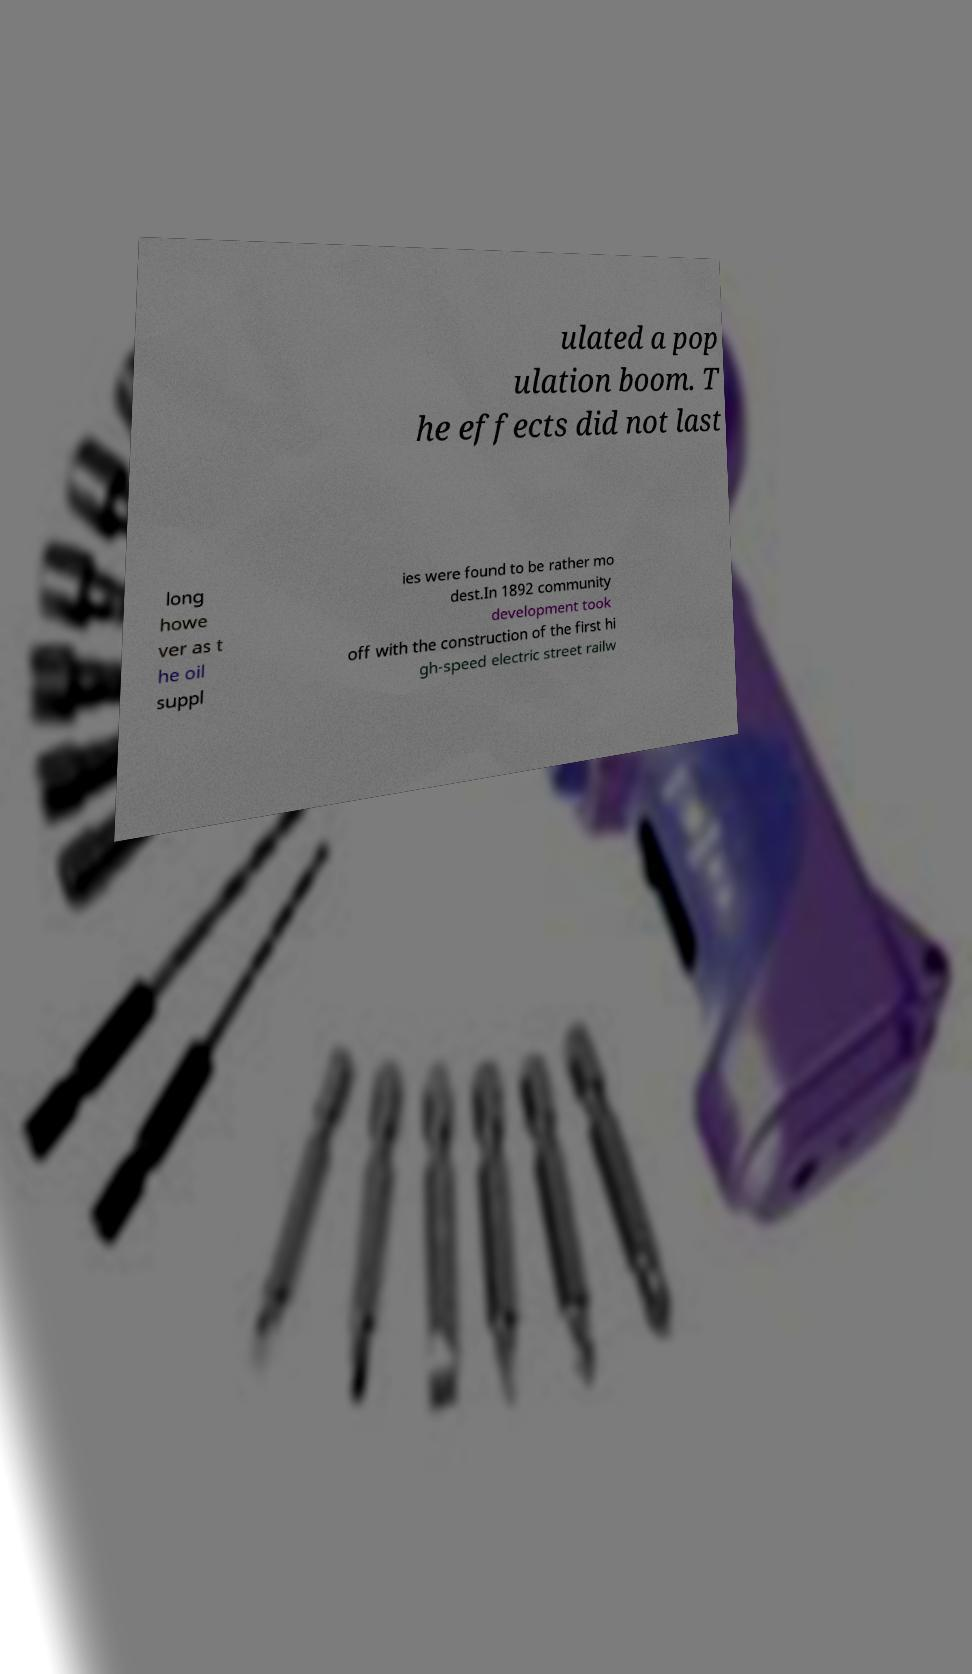Could you extract and type out the text from this image? ulated a pop ulation boom. T he effects did not last long howe ver as t he oil suppl ies were found to be rather mo dest.In 1892 community development took off with the construction of the first hi gh-speed electric street railw 